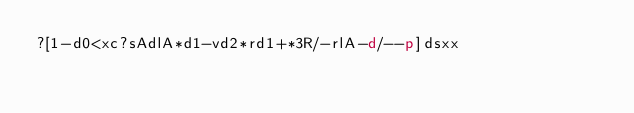<code> <loc_0><loc_0><loc_500><loc_500><_dc_>?[1-d0<xc?sAdlA*d1-vd2*rd1+*3R/-rlA-d/--p]dsxx</code> 